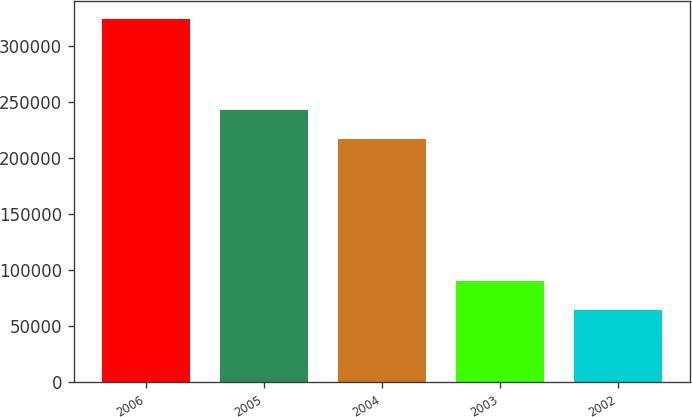Convert chart. <chart><loc_0><loc_0><loc_500><loc_500><bar_chart><fcel>2006<fcel>2005<fcel>2004<fcel>2003<fcel>2002<nl><fcel>323950<fcel>242590<fcel>216600<fcel>90040<fcel>64050<nl></chart> 